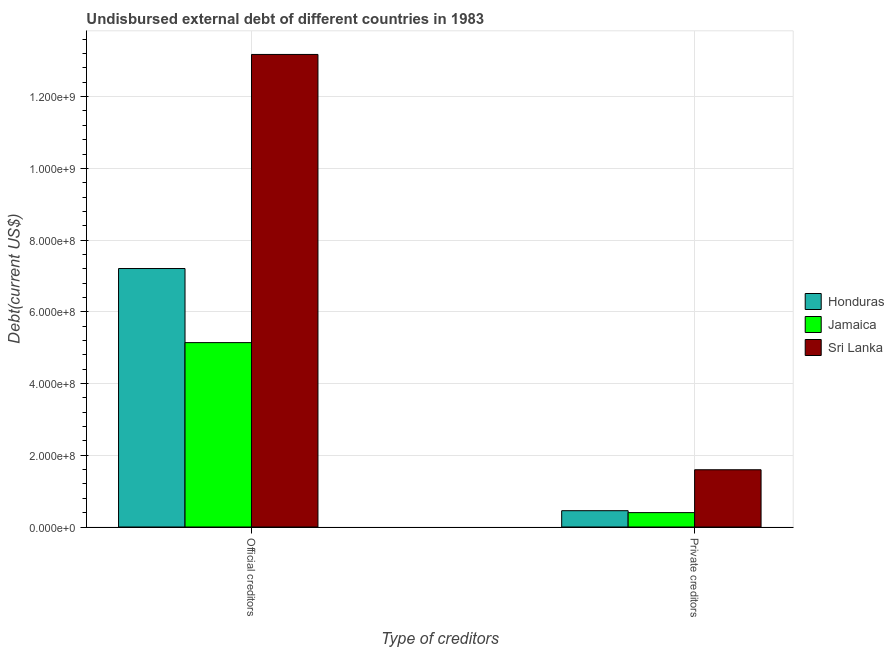Are the number of bars per tick equal to the number of legend labels?
Make the answer very short. Yes. Are the number of bars on each tick of the X-axis equal?
Provide a short and direct response. Yes. How many bars are there on the 2nd tick from the left?
Offer a very short reply. 3. What is the label of the 2nd group of bars from the left?
Make the answer very short. Private creditors. What is the undisbursed external debt of official creditors in Honduras?
Offer a terse response. 7.21e+08. Across all countries, what is the maximum undisbursed external debt of private creditors?
Your answer should be very brief. 1.60e+08. Across all countries, what is the minimum undisbursed external debt of private creditors?
Provide a short and direct response. 4.01e+07. In which country was the undisbursed external debt of official creditors maximum?
Keep it short and to the point. Sri Lanka. In which country was the undisbursed external debt of private creditors minimum?
Make the answer very short. Jamaica. What is the total undisbursed external debt of private creditors in the graph?
Ensure brevity in your answer.  2.45e+08. What is the difference between the undisbursed external debt of official creditors in Sri Lanka and that in Jamaica?
Make the answer very short. 8.03e+08. What is the difference between the undisbursed external debt of private creditors in Honduras and the undisbursed external debt of official creditors in Sri Lanka?
Keep it short and to the point. -1.27e+09. What is the average undisbursed external debt of private creditors per country?
Ensure brevity in your answer.  8.18e+07. What is the difference between the undisbursed external debt of official creditors and undisbursed external debt of private creditors in Sri Lanka?
Your answer should be compact. 1.16e+09. What is the ratio of the undisbursed external debt of private creditors in Jamaica to that in Sri Lanka?
Offer a very short reply. 0.25. What does the 2nd bar from the left in Private creditors represents?
Offer a very short reply. Jamaica. What does the 3rd bar from the right in Official creditors represents?
Make the answer very short. Honduras. How many bars are there?
Offer a terse response. 6. Are all the bars in the graph horizontal?
Give a very brief answer. No. Are the values on the major ticks of Y-axis written in scientific E-notation?
Your answer should be compact. Yes. Does the graph contain any zero values?
Make the answer very short. No. How are the legend labels stacked?
Keep it short and to the point. Vertical. What is the title of the graph?
Give a very brief answer. Undisbursed external debt of different countries in 1983. What is the label or title of the X-axis?
Ensure brevity in your answer.  Type of creditors. What is the label or title of the Y-axis?
Your answer should be compact. Debt(current US$). What is the Debt(current US$) of Honduras in Official creditors?
Keep it short and to the point. 7.21e+08. What is the Debt(current US$) of Jamaica in Official creditors?
Offer a terse response. 5.14e+08. What is the Debt(current US$) of Sri Lanka in Official creditors?
Ensure brevity in your answer.  1.32e+09. What is the Debt(current US$) of Honduras in Private creditors?
Keep it short and to the point. 4.55e+07. What is the Debt(current US$) of Jamaica in Private creditors?
Keep it short and to the point. 4.01e+07. What is the Debt(current US$) of Sri Lanka in Private creditors?
Offer a terse response. 1.60e+08. Across all Type of creditors, what is the maximum Debt(current US$) in Honduras?
Offer a very short reply. 7.21e+08. Across all Type of creditors, what is the maximum Debt(current US$) in Jamaica?
Keep it short and to the point. 5.14e+08. Across all Type of creditors, what is the maximum Debt(current US$) of Sri Lanka?
Offer a terse response. 1.32e+09. Across all Type of creditors, what is the minimum Debt(current US$) in Honduras?
Give a very brief answer. 4.55e+07. Across all Type of creditors, what is the minimum Debt(current US$) of Jamaica?
Offer a terse response. 4.01e+07. Across all Type of creditors, what is the minimum Debt(current US$) in Sri Lanka?
Your response must be concise. 1.60e+08. What is the total Debt(current US$) of Honduras in the graph?
Your answer should be compact. 7.66e+08. What is the total Debt(current US$) in Jamaica in the graph?
Your response must be concise. 5.54e+08. What is the total Debt(current US$) in Sri Lanka in the graph?
Provide a succinct answer. 1.48e+09. What is the difference between the Debt(current US$) in Honduras in Official creditors and that in Private creditors?
Your response must be concise. 6.75e+08. What is the difference between the Debt(current US$) of Jamaica in Official creditors and that in Private creditors?
Provide a short and direct response. 4.74e+08. What is the difference between the Debt(current US$) in Sri Lanka in Official creditors and that in Private creditors?
Make the answer very short. 1.16e+09. What is the difference between the Debt(current US$) in Honduras in Official creditors and the Debt(current US$) in Jamaica in Private creditors?
Offer a terse response. 6.81e+08. What is the difference between the Debt(current US$) of Honduras in Official creditors and the Debt(current US$) of Sri Lanka in Private creditors?
Give a very brief answer. 5.61e+08. What is the difference between the Debt(current US$) in Jamaica in Official creditors and the Debt(current US$) in Sri Lanka in Private creditors?
Offer a terse response. 3.54e+08. What is the average Debt(current US$) in Honduras per Type of creditors?
Make the answer very short. 3.83e+08. What is the average Debt(current US$) of Jamaica per Type of creditors?
Provide a short and direct response. 2.77e+08. What is the average Debt(current US$) of Sri Lanka per Type of creditors?
Offer a very short reply. 7.39e+08. What is the difference between the Debt(current US$) in Honduras and Debt(current US$) in Jamaica in Official creditors?
Give a very brief answer. 2.07e+08. What is the difference between the Debt(current US$) of Honduras and Debt(current US$) of Sri Lanka in Official creditors?
Your answer should be very brief. -5.97e+08. What is the difference between the Debt(current US$) in Jamaica and Debt(current US$) in Sri Lanka in Official creditors?
Keep it short and to the point. -8.03e+08. What is the difference between the Debt(current US$) of Honduras and Debt(current US$) of Jamaica in Private creditors?
Give a very brief answer. 5.36e+06. What is the difference between the Debt(current US$) in Honduras and Debt(current US$) in Sri Lanka in Private creditors?
Provide a succinct answer. -1.14e+08. What is the difference between the Debt(current US$) in Jamaica and Debt(current US$) in Sri Lanka in Private creditors?
Your answer should be compact. -1.20e+08. What is the ratio of the Debt(current US$) of Honduras in Official creditors to that in Private creditors?
Make the answer very short. 15.85. What is the ratio of the Debt(current US$) of Jamaica in Official creditors to that in Private creditors?
Your answer should be compact. 12.82. What is the ratio of the Debt(current US$) of Sri Lanka in Official creditors to that in Private creditors?
Offer a very short reply. 8.25. What is the difference between the highest and the second highest Debt(current US$) in Honduras?
Provide a short and direct response. 6.75e+08. What is the difference between the highest and the second highest Debt(current US$) in Jamaica?
Give a very brief answer. 4.74e+08. What is the difference between the highest and the second highest Debt(current US$) of Sri Lanka?
Offer a terse response. 1.16e+09. What is the difference between the highest and the lowest Debt(current US$) in Honduras?
Offer a very short reply. 6.75e+08. What is the difference between the highest and the lowest Debt(current US$) of Jamaica?
Keep it short and to the point. 4.74e+08. What is the difference between the highest and the lowest Debt(current US$) in Sri Lanka?
Offer a very short reply. 1.16e+09. 